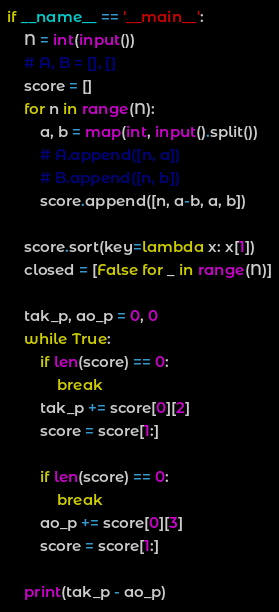Convert code to text. <code><loc_0><loc_0><loc_500><loc_500><_Python_>if __name__ == '__main__':
    N = int(input())
    # A, B = [], []
    score = []
    for n in range(N):
        a, b = map(int, input().split())
        # A.append([n, a])
        # B.append([n, b])
        score.append([n, a-b, a, b])

    score.sort(key=lambda x: x[1])
    closed = [False for _ in range(N)]

    tak_p, ao_p = 0, 0
    while True:
        if len(score) == 0:
            break
        tak_p += score[0][2]
        score = score[1:]

        if len(score) == 0:
            break
        ao_p += score[0][3]
        score = score[1:]

    print(tak_p - ao_p)
</code> 